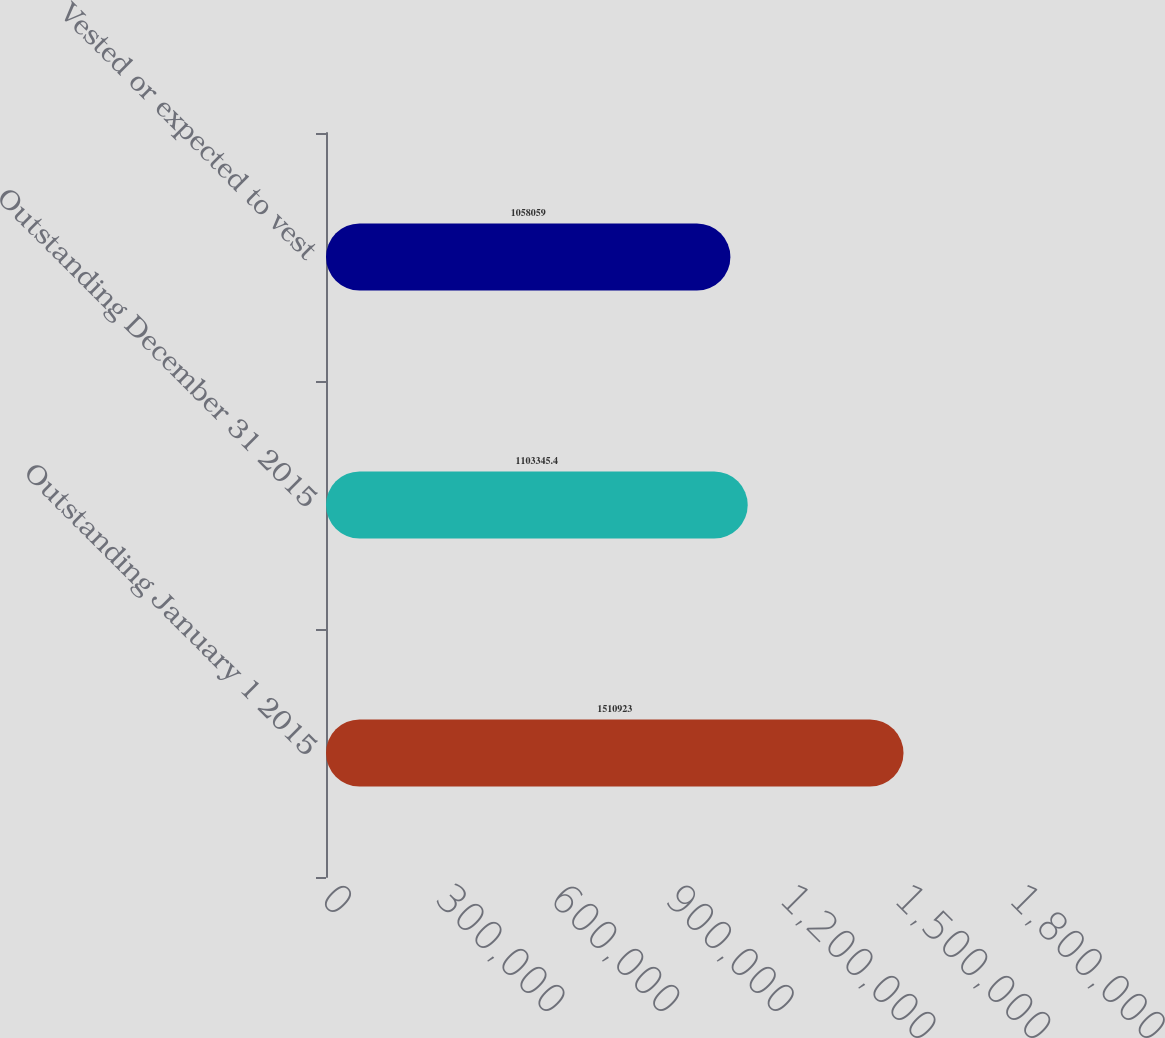Convert chart. <chart><loc_0><loc_0><loc_500><loc_500><bar_chart><fcel>Outstanding January 1 2015<fcel>Outstanding December 31 2015<fcel>Vested or expected to vest<nl><fcel>1.51092e+06<fcel>1.10335e+06<fcel>1.05806e+06<nl></chart> 